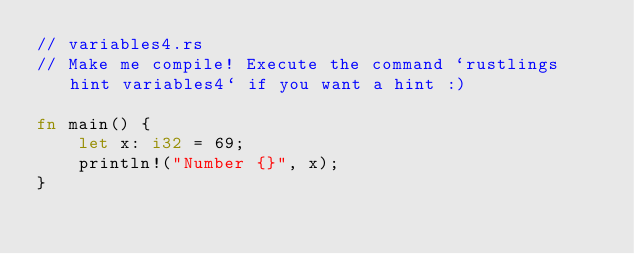<code> <loc_0><loc_0><loc_500><loc_500><_Rust_>// variables4.rs
// Make me compile! Execute the command `rustlings hint variables4` if you want a hint :)

fn main() {
    let x: i32 = 69;
    println!("Number {}", x);
}
</code> 